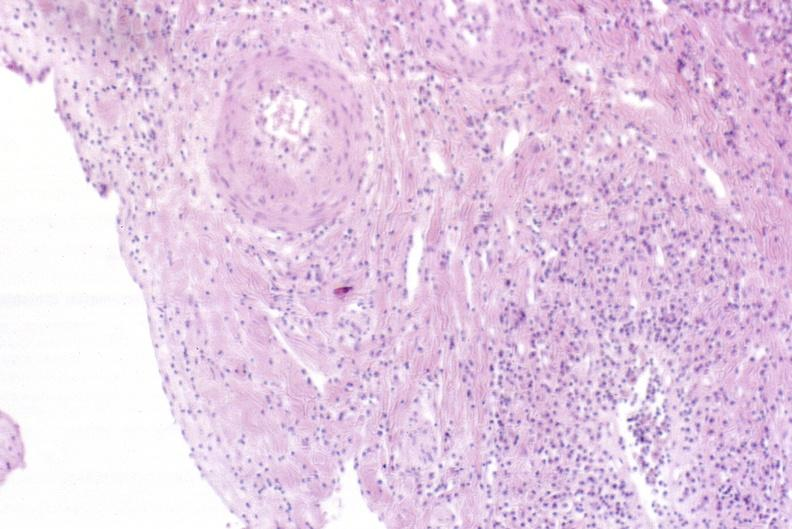s hypertrophic gastritis present?
Answer the question using a single word or phrase. No 